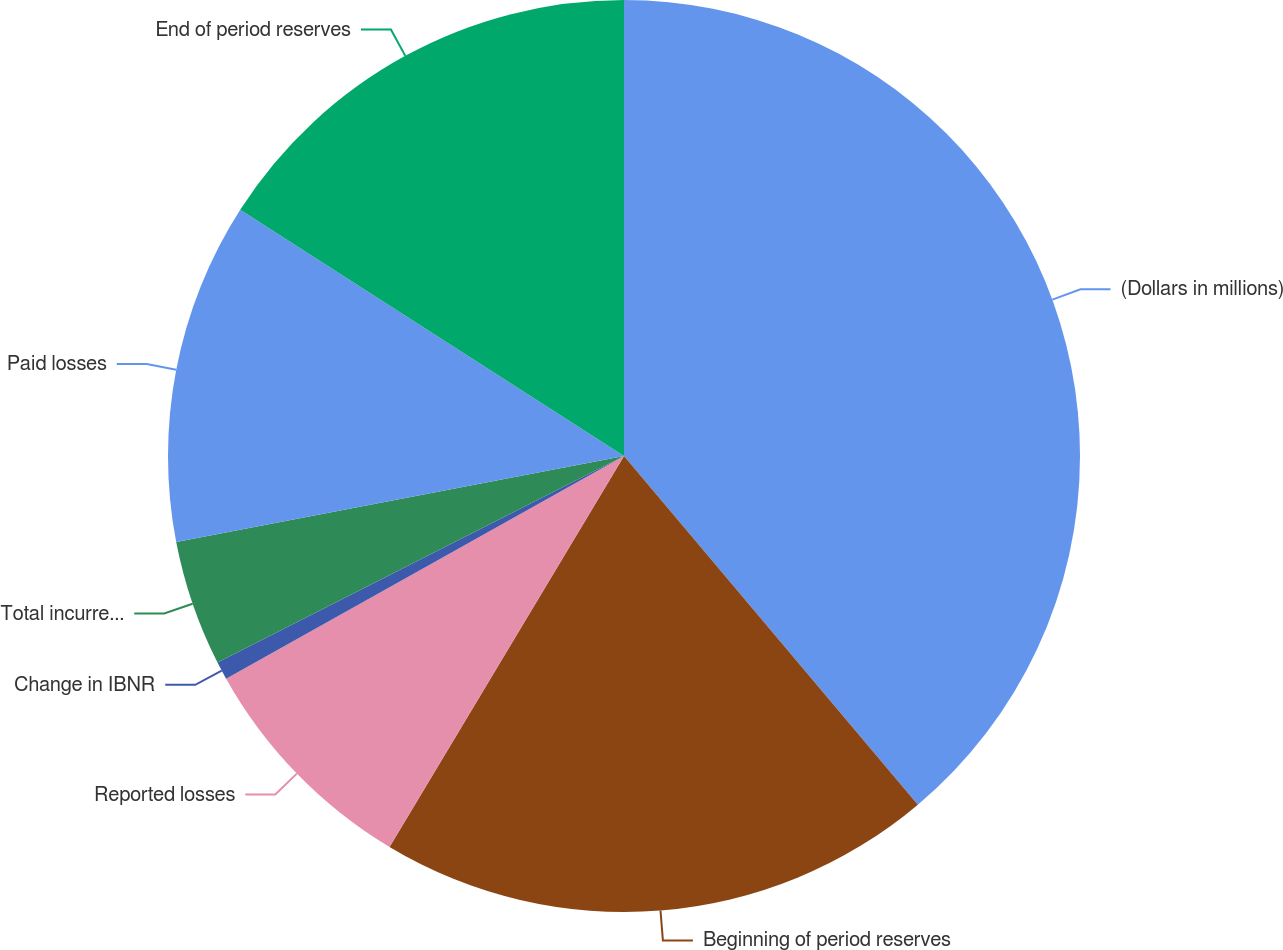Convert chart to OTSL. <chart><loc_0><loc_0><loc_500><loc_500><pie_chart><fcel>(Dollars in millions)<fcel>Beginning of period reserves<fcel>Reported losses<fcel>Change in IBNR<fcel>Total incurred losses and LAE<fcel>Paid losses<fcel>End of period reserves<nl><fcel>38.85%<fcel>19.74%<fcel>8.28%<fcel>0.64%<fcel>4.46%<fcel>12.1%<fcel>15.92%<nl></chart> 